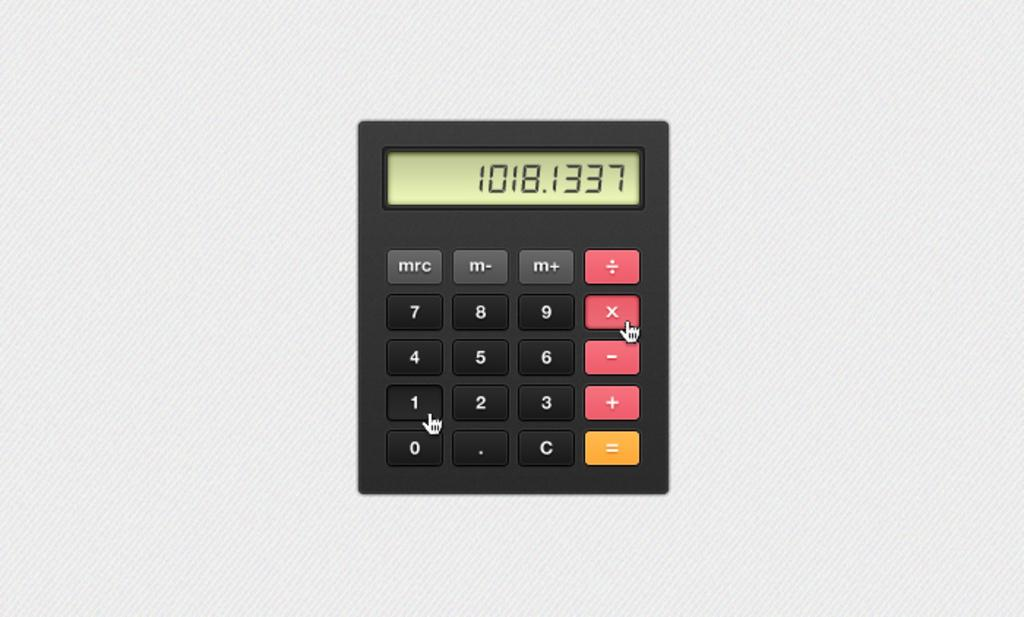<image>
Create a compact narrative representing the image presented. A calculator with black, orange, and yellow buttons has the number 1018. 